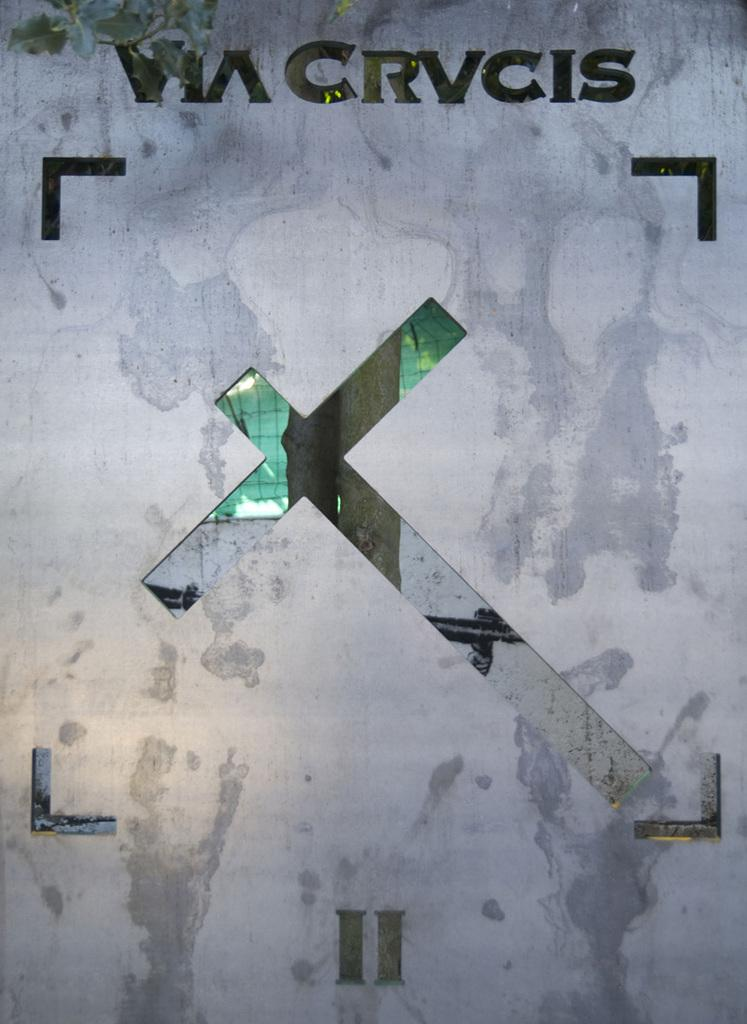<image>
Provide a brief description of the given image. A diagonal cross is on a gray background with the text "via crvcis" above. 